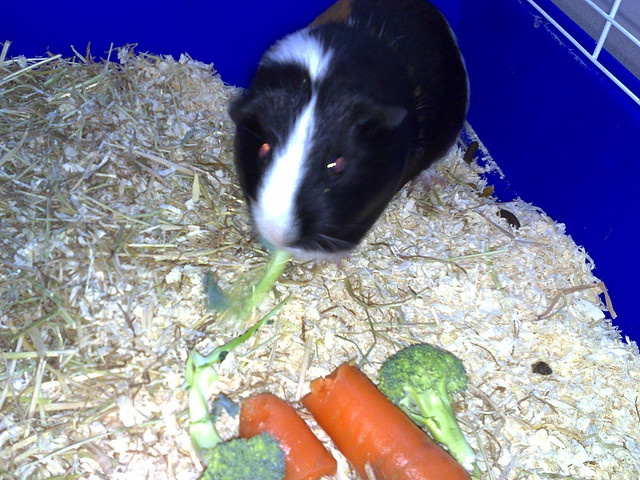Describe the objects in this image and their specific colors. I can see carrot in darkblue, red, salmon, and brown tones, broccoli in darkblue, lightgreen, and green tones, broccoli in darkblue, darkgray, beige, and lightgreen tones, and carrot in darkblue, salmon, and red tones in this image. 